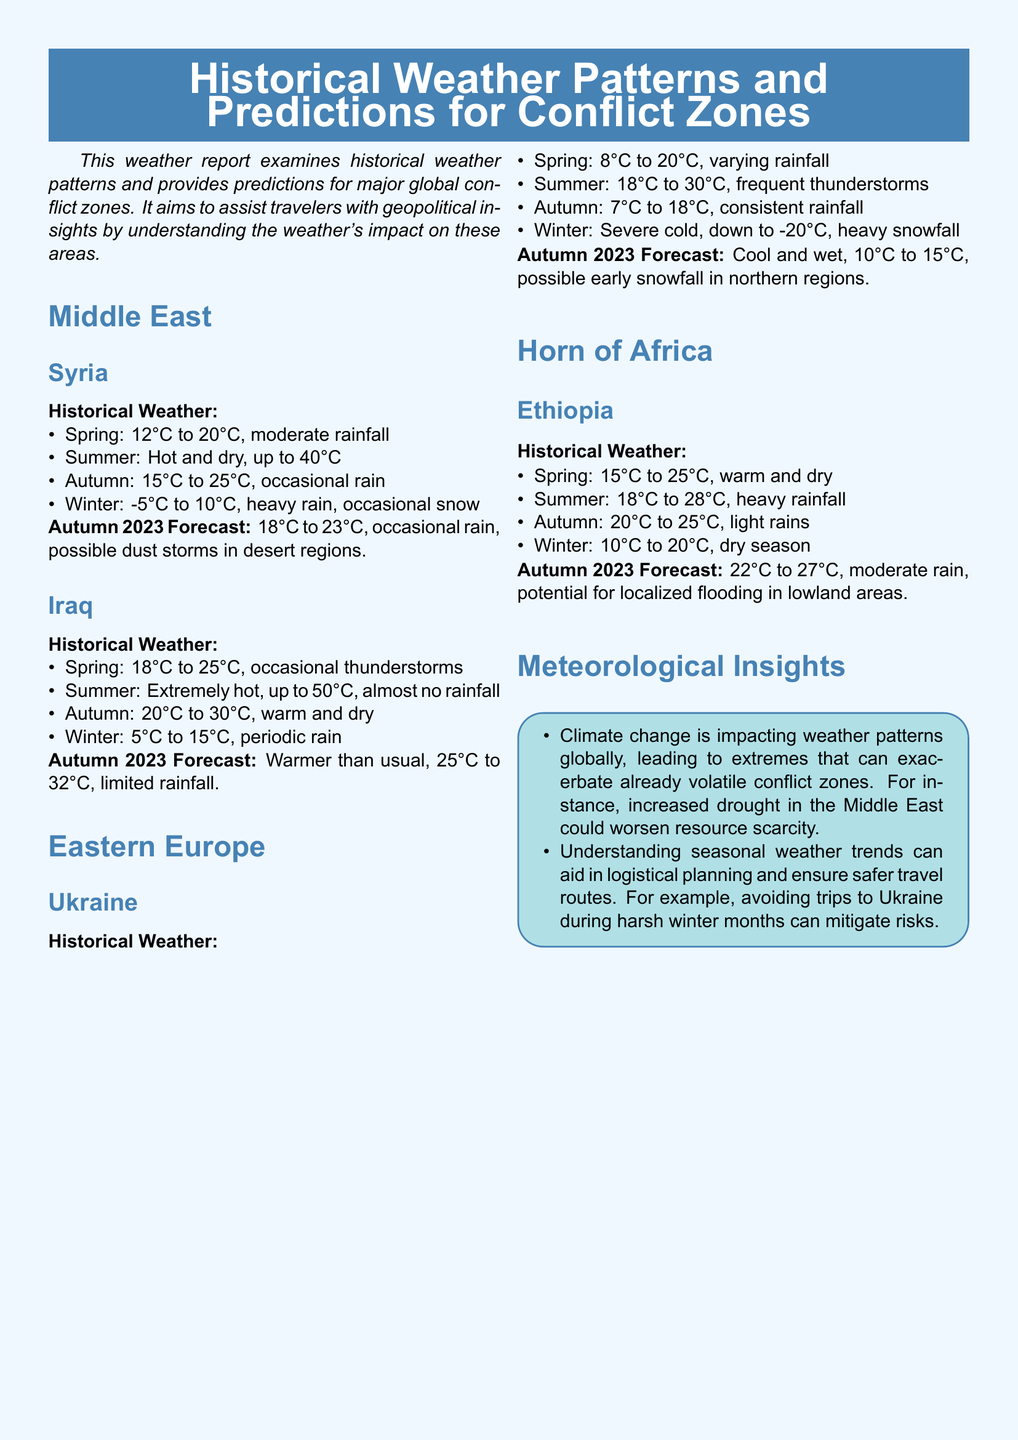What is the temperature range in Syria during Spring? The temperature range in Syria during Spring is between 12°C to 20°C.
Answer: 12°C to 20°C What is the forecasted temperature for Iraq in Autumn 2023? The forecasted temperature for Iraq in Autumn 2023 is 25°C to 32°C.
Answer: 25°C to 32°C What type of weather is expected in Ukraine during Autumn 2023? The expected weather in Ukraine during Autumn 2023 is cool and wet with possible early snowfall.
Answer: Cool and wet, possible early snowfall What is the temperature range in Ethiopia during Winter? The temperature range in Ethiopia during Winter is between 10°C to 20°C.
Answer: 10°C to 20°C What is the season with the highest temperatures in Iraq? Summer is the season with the highest temperatures in Iraq.
Answer: Summer What can increased drought in the Middle East worsen? Increased drought can worsen resource scarcity in the Middle East.
Answer: Resource scarcity How does understanding seasonal weather trends aid travelers? Understanding seasonal weather trends aids travelers by helping with logistical planning and identifying safer travel routes.
Answer: Logistical planning What is a notable characteristic of Autumn weather in Syria? A notable characteristic of Autumn weather in Syria is occasional rain.
Answer: Occasional rain What is the general impact of climate change mentioned in the document? Climate change is leading to extremes that can exacerbate already volatile conflict zones.
Answer: Extremes that exacerbate conflict zones 